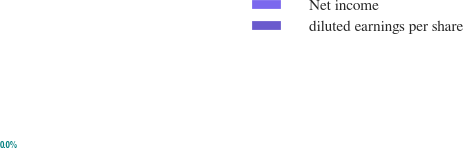Convert chart. <chart><loc_0><loc_0><loc_500><loc_500><pie_chart><fcel>Net income<fcel>diluted earnings per share<nl><fcel>100.0%<fcel>0.0%<nl></chart> 